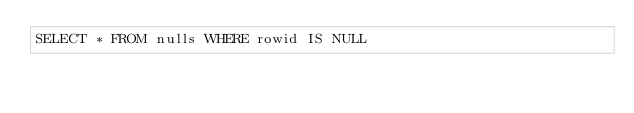Convert code to text. <code><loc_0><loc_0><loc_500><loc_500><_SQL_>SELECT * FROM nulls WHERE rowid IS NULL
</code> 